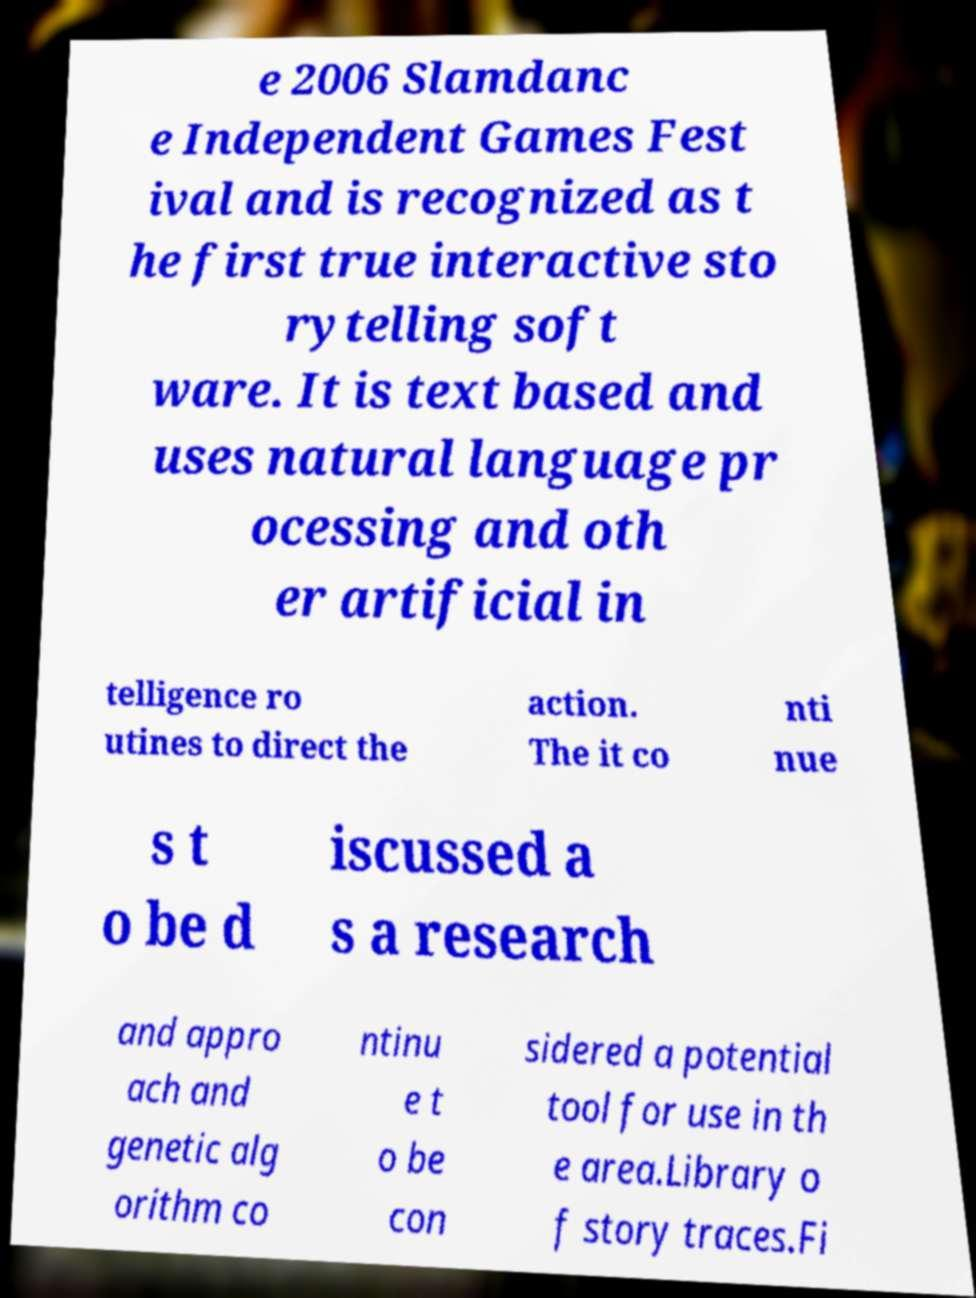Can you read and provide the text displayed in the image?This photo seems to have some interesting text. Can you extract and type it out for me? e 2006 Slamdanc e Independent Games Fest ival and is recognized as t he first true interactive sto rytelling soft ware. It is text based and uses natural language pr ocessing and oth er artificial in telligence ro utines to direct the action. The it co nti nue s t o be d iscussed a s a research and appro ach and genetic alg orithm co ntinu e t o be con sidered a potential tool for use in th e area.Library o f story traces.Fi 